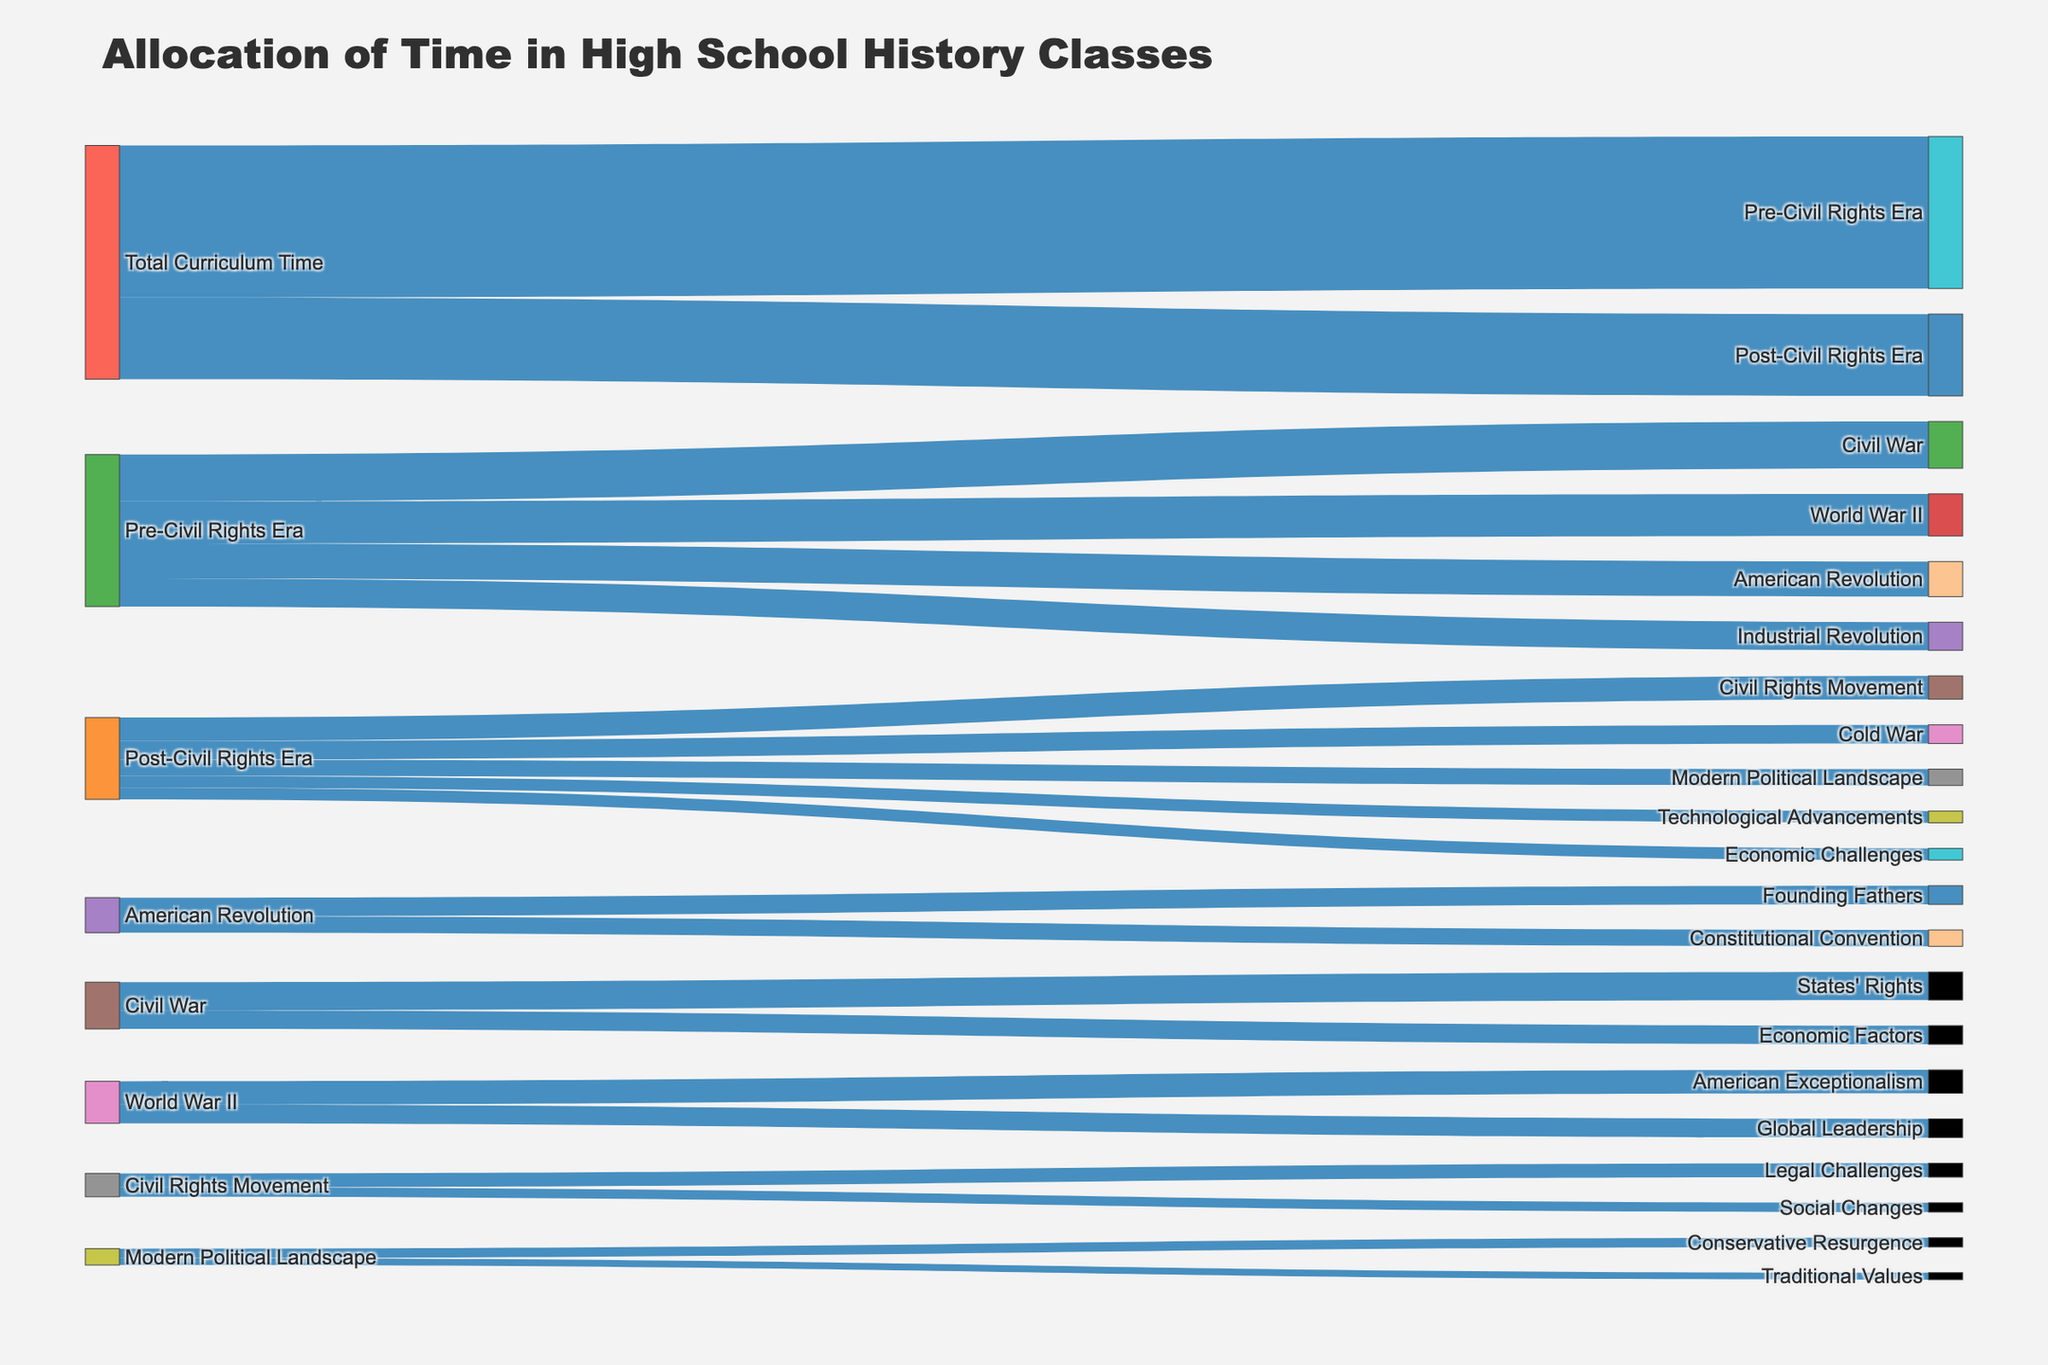What is the title of the figure? The title is located at the top of the figure and provides a brief description of the information presented in the diagram.
Answer: Allocation of Time in High School History Classes Which era has the most curriculum time allocated? By comparing the values connected to "Total Curriculum Time," the Pre-Civil Rights Era has 65 units of time, whereas the Post-Civil Rights Era has 35 units.
Answer: Pre-Civil Rights Era How much time is spent on the American Revolution compared to the Civil Rights Movement? The flow from the Pre-Civil Rights Era to the American Revolution shows 15 units of time, while the flow from the Post-Civil Rights Era to the Civil Rights Movement shows 10 units.
Answer: 5 units more on the American Revolution What is the total time allocated to the Civil War and World War II combined? Adding the values for the Civil War (20) and World War II (18) connected to the Pre-Civil Rights Era gives the combined total.
Answer: 38 units Which topic has more time allocated, Cold War or Modern Political Landscape within the Post-Civil Rights Era? By comparing the flows under the Post-Civil Rights Era, the Cold War has 8 units, and the Modern Political Landscape has 7 units.
Answer: Cold War How is the time for the American Revolution distributed among its subtopics? The American Revolution is split into Founding Fathers (8 units) and Constitutional Convention (7 units). Adding these gives the total.
Answer: 8 units for Founding Fathers, 7 units for Constitutional Convention Which subject received more time, Economic Factors of the Civil War or Legal Challenges of the Civil Rights Movement? Looking at the respective flows, Economic Factors of the Civil War has 8 units, and Legal Challenges of the Civil Rights Movement has 6 units.
Answer: Economic Factors of the Civil War How much time is allocated to Traditional Values within the Modern Political Landscape? Under Modern Political Landscape in the Post-Civil Rights Era, Traditional Values is allocated 3 units of time.
Answer: 3 units What topics are covered under World War II in the Pre-Civil Rights Era? The time connected to World War II is divided into American Exceptionalism (10 units) and Global Leadership (8 units).
Answer: American Exceptionalism and Global Leadership 